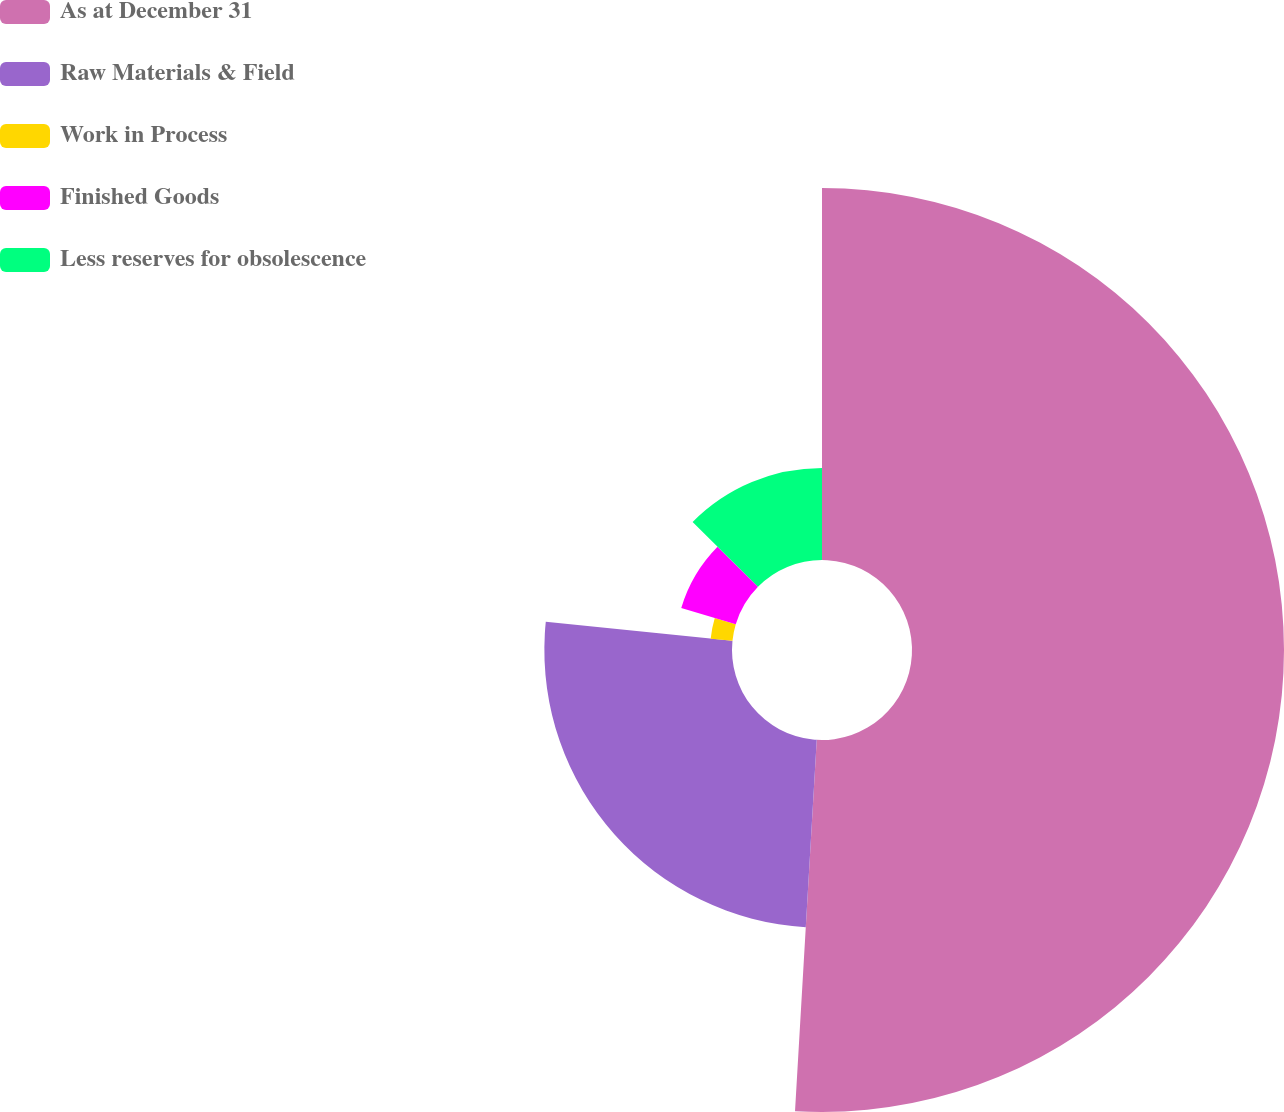Convert chart. <chart><loc_0><loc_0><loc_500><loc_500><pie_chart><fcel>As at December 31<fcel>Raw Materials & Field<fcel>Work in Process<fcel>Finished Goods<fcel>Less reserves for obsolescence<nl><fcel>50.93%<fcel>25.69%<fcel>3.0%<fcel>7.79%<fcel>12.59%<nl></chart> 